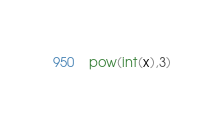<code> <loc_0><loc_0><loc_500><loc_500><_Python_>pow(int(x),3)</code> 